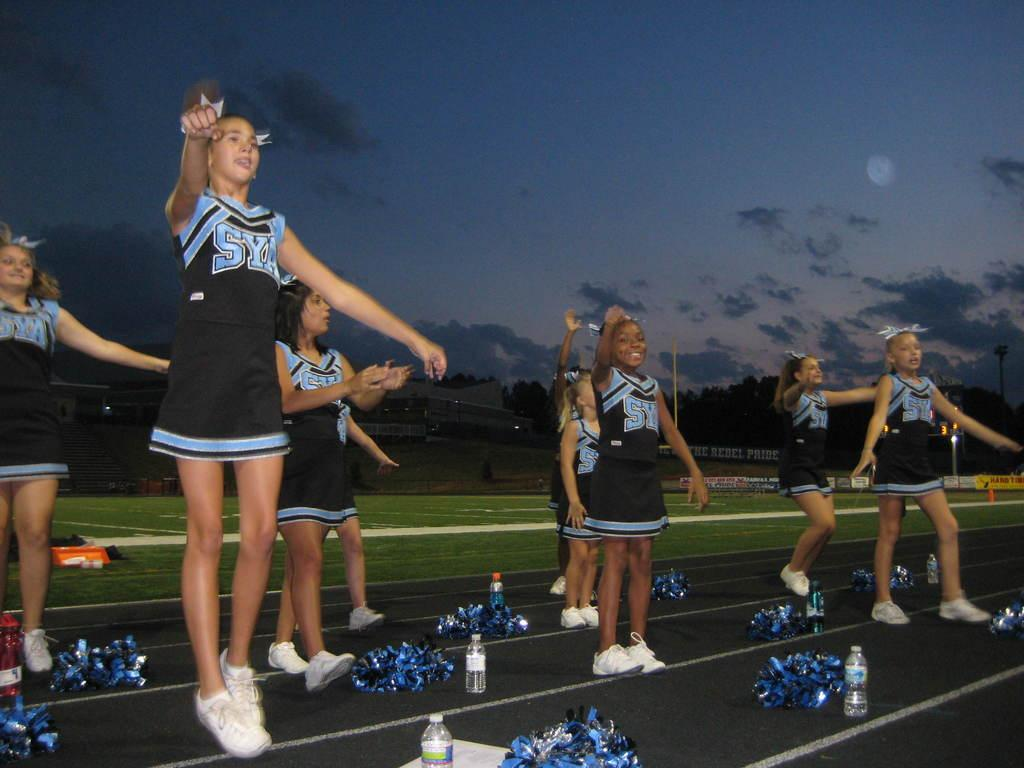<image>
Render a clear and concise summary of the photo. Cheerleaders wear uniforms with SYA on the front. 